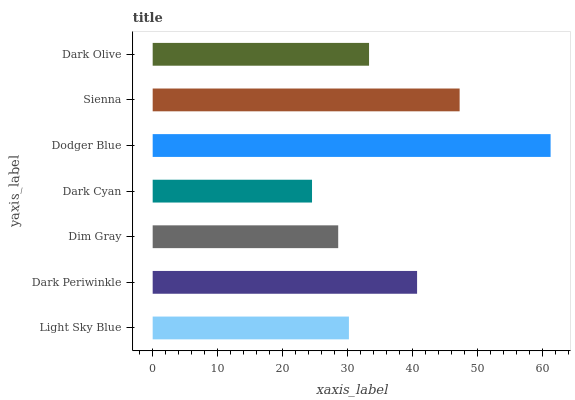Is Dark Cyan the minimum?
Answer yes or no. Yes. Is Dodger Blue the maximum?
Answer yes or no. Yes. Is Dark Periwinkle the minimum?
Answer yes or no. No. Is Dark Periwinkle the maximum?
Answer yes or no. No. Is Dark Periwinkle greater than Light Sky Blue?
Answer yes or no. Yes. Is Light Sky Blue less than Dark Periwinkle?
Answer yes or no. Yes. Is Light Sky Blue greater than Dark Periwinkle?
Answer yes or no. No. Is Dark Periwinkle less than Light Sky Blue?
Answer yes or no. No. Is Dark Olive the high median?
Answer yes or no. Yes. Is Dark Olive the low median?
Answer yes or no. Yes. Is Light Sky Blue the high median?
Answer yes or no. No. Is Sienna the low median?
Answer yes or no. No. 